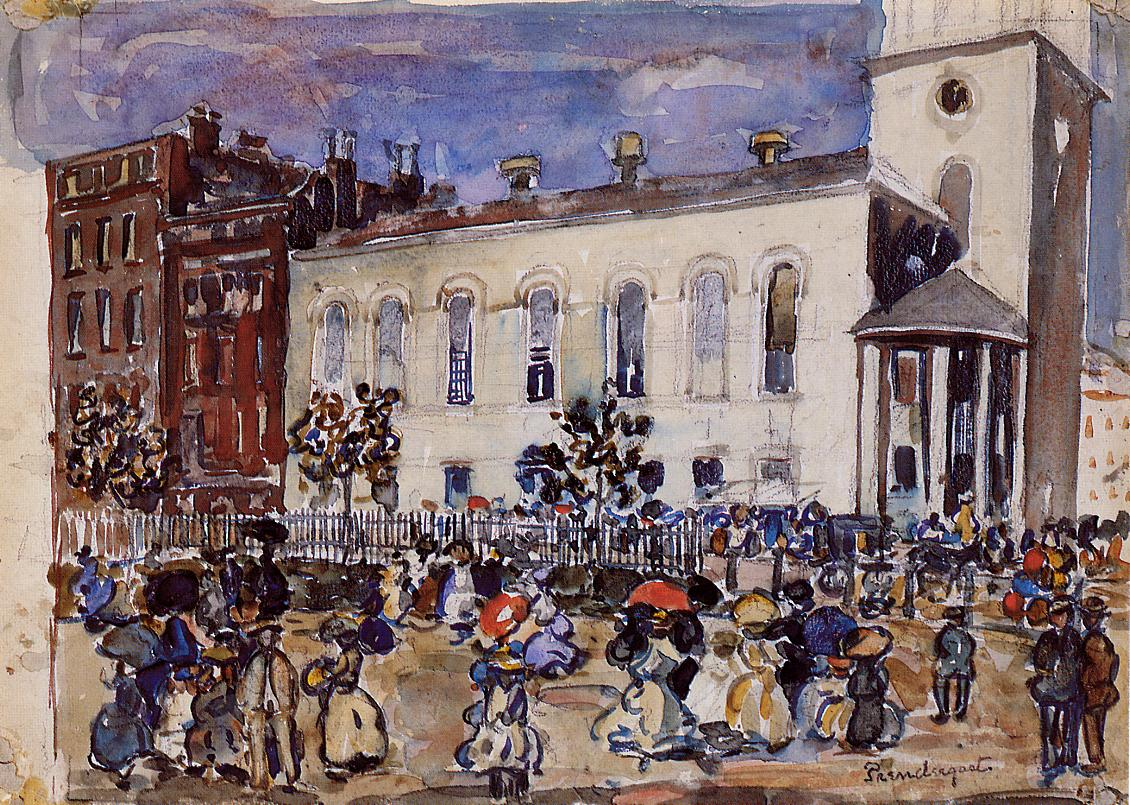Can you elaborate on the elements of the picture provided? The image is a lively depiction of a bustling street scene, captured in the impressionist style. The artist has used a loose, sketchy technique to emphasize the movement and energy of the scene. The canvas is filled with figures dressed in early 20th century clothing, engaged in various activities such as walking, talking, and carrying baskets. The colors used are primarily earth tones, with blue and green accents adding depth and contrast. Dominating the background is a white building with a tall tower, its architectural details rendered with the same loose brushwork as the figures. The overall effect is a dynamic snapshot of life in a bygone era, captured with an artist's eye for detail and color. 